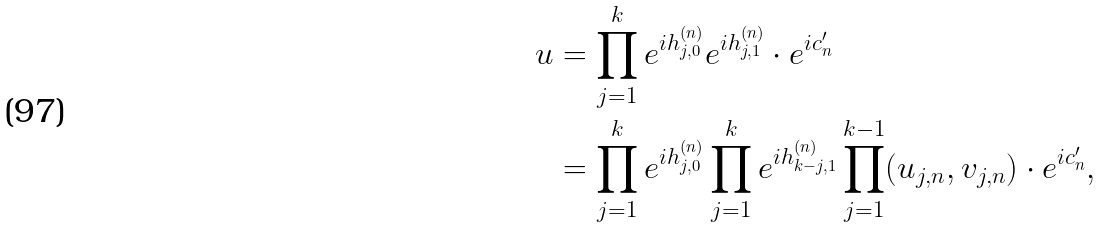<formula> <loc_0><loc_0><loc_500><loc_500>u & = \prod _ { j = 1 } ^ { k } e ^ { i h _ { j , 0 } ^ { ( n ) } } e ^ { i h _ { j , 1 } ^ { ( n ) } } \cdot e ^ { i c _ { n } ^ { \prime } } \\ & = \prod _ { j = 1 } ^ { k } e ^ { i h _ { j , 0 } ^ { ( n ) } } \prod _ { j = 1 } ^ { k } e ^ { i h _ { k - j , 1 } ^ { ( n ) } } \prod _ { j = 1 } ^ { k - 1 } ( u _ { j , n } , v _ { j , n } ) \cdot e ^ { i c _ { n } ^ { \prime } } ,</formula> 